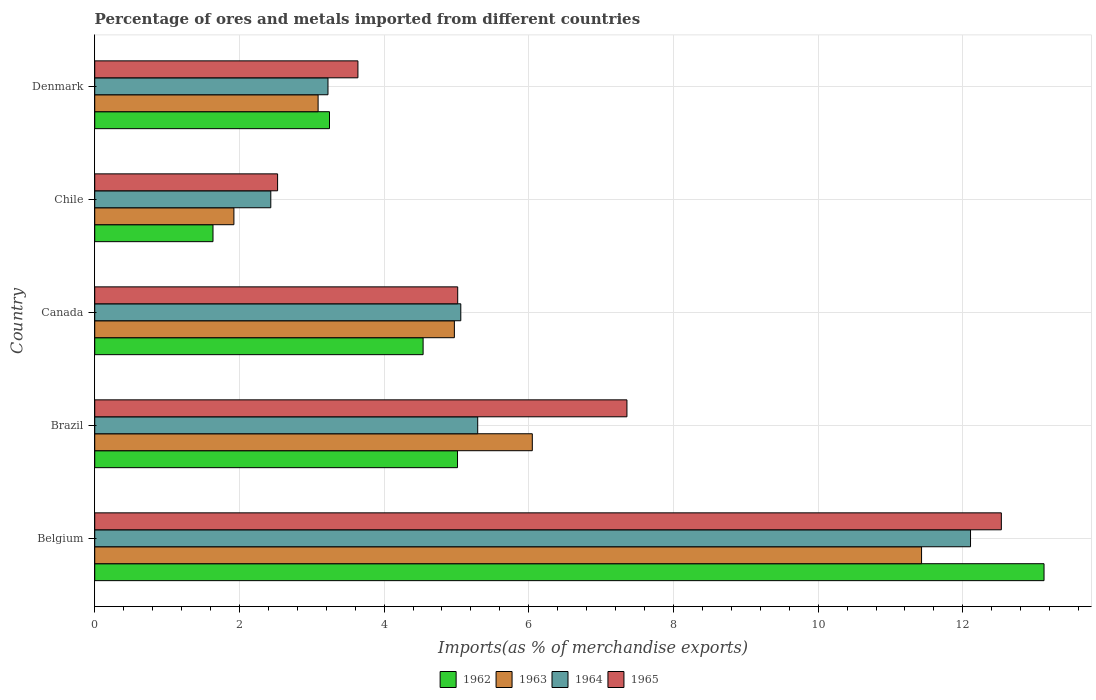How many different coloured bars are there?
Your response must be concise. 4. How many groups of bars are there?
Make the answer very short. 5. How many bars are there on the 1st tick from the bottom?
Give a very brief answer. 4. What is the label of the 2nd group of bars from the top?
Offer a terse response. Chile. What is the percentage of imports to different countries in 1965 in Belgium?
Make the answer very short. 12.53. Across all countries, what is the maximum percentage of imports to different countries in 1964?
Make the answer very short. 12.11. Across all countries, what is the minimum percentage of imports to different countries in 1964?
Your answer should be compact. 2.43. In which country was the percentage of imports to different countries in 1965 minimum?
Keep it short and to the point. Chile. What is the total percentage of imports to different countries in 1963 in the graph?
Offer a terse response. 27.46. What is the difference between the percentage of imports to different countries in 1964 in Belgium and that in Canada?
Ensure brevity in your answer.  7.05. What is the difference between the percentage of imports to different countries in 1963 in Brazil and the percentage of imports to different countries in 1964 in Canada?
Ensure brevity in your answer.  0.99. What is the average percentage of imports to different countries in 1963 per country?
Your answer should be very brief. 5.49. What is the difference between the percentage of imports to different countries in 1962 and percentage of imports to different countries in 1963 in Chile?
Your answer should be very brief. -0.29. What is the ratio of the percentage of imports to different countries in 1964 in Belgium to that in Chile?
Make the answer very short. 4.97. Is the percentage of imports to different countries in 1962 in Chile less than that in Denmark?
Your answer should be compact. Yes. Is the difference between the percentage of imports to different countries in 1962 in Brazil and Canada greater than the difference between the percentage of imports to different countries in 1963 in Brazil and Canada?
Provide a short and direct response. No. What is the difference between the highest and the second highest percentage of imports to different countries in 1965?
Your answer should be very brief. 5.18. What is the difference between the highest and the lowest percentage of imports to different countries in 1964?
Your answer should be compact. 9.67. In how many countries, is the percentage of imports to different countries in 1963 greater than the average percentage of imports to different countries in 1963 taken over all countries?
Your response must be concise. 2. Is the sum of the percentage of imports to different countries in 1965 in Brazil and Chile greater than the maximum percentage of imports to different countries in 1963 across all countries?
Make the answer very short. No. Is it the case that in every country, the sum of the percentage of imports to different countries in 1963 and percentage of imports to different countries in 1964 is greater than the sum of percentage of imports to different countries in 1962 and percentage of imports to different countries in 1965?
Provide a short and direct response. No. What does the 4th bar from the top in Denmark represents?
Make the answer very short. 1962. What does the 3rd bar from the bottom in Chile represents?
Your answer should be compact. 1964. Are all the bars in the graph horizontal?
Your answer should be compact. Yes. How many countries are there in the graph?
Your response must be concise. 5. Does the graph contain any zero values?
Provide a succinct answer. No. Where does the legend appear in the graph?
Your answer should be very brief. Bottom center. How many legend labels are there?
Give a very brief answer. 4. What is the title of the graph?
Keep it short and to the point. Percentage of ores and metals imported from different countries. What is the label or title of the X-axis?
Make the answer very short. Imports(as % of merchandise exports). What is the Imports(as % of merchandise exports) in 1962 in Belgium?
Keep it short and to the point. 13.12. What is the Imports(as % of merchandise exports) in 1963 in Belgium?
Your response must be concise. 11.43. What is the Imports(as % of merchandise exports) of 1964 in Belgium?
Provide a short and direct response. 12.11. What is the Imports(as % of merchandise exports) in 1965 in Belgium?
Provide a succinct answer. 12.53. What is the Imports(as % of merchandise exports) of 1962 in Brazil?
Keep it short and to the point. 5.01. What is the Imports(as % of merchandise exports) of 1963 in Brazil?
Your answer should be very brief. 6.05. What is the Imports(as % of merchandise exports) of 1964 in Brazil?
Your answer should be compact. 5.29. What is the Imports(as % of merchandise exports) in 1965 in Brazil?
Your response must be concise. 7.36. What is the Imports(as % of merchandise exports) of 1962 in Canada?
Provide a short and direct response. 4.54. What is the Imports(as % of merchandise exports) in 1963 in Canada?
Your answer should be very brief. 4.97. What is the Imports(as % of merchandise exports) in 1964 in Canada?
Ensure brevity in your answer.  5.06. What is the Imports(as % of merchandise exports) of 1965 in Canada?
Keep it short and to the point. 5.02. What is the Imports(as % of merchandise exports) of 1962 in Chile?
Offer a terse response. 1.63. What is the Imports(as % of merchandise exports) in 1963 in Chile?
Provide a short and direct response. 1.92. What is the Imports(as % of merchandise exports) in 1964 in Chile?
Offer a very short reply. 2.43. What is the Imports(as % of merchandise exports) of 1965 in Chile?
Your answer should be compact. 2.53. What is the Imports(as % of merchandise exports) in 1962 in Denmark?
Make the answer very short. 3.25. What is the Imports(as % of merchandise exports) of 1963 in Denmark?
Provide a short and direct response. 3.09. What is the Imports(as % of merchandise exports) of 1964 in Denmark?
Offer a terse response. 3.22. What is the Imports(as % of merchandise exports) in 1965 in Denmark?
Ensure brevity in your answer.  3.64. Across all countries, what is the maximum Imports(as % of merchandise exports) in 1962?
Ensure brevity in your answer.  13.12. Across all countries, what is the maximum Imports(as % of merchandise exports) of 1963?
Your response must be concise. 11.43. Across all countries, what is the maximum Imports(as % of merchandise exports) in 1964?
Your answer should be compact. 12.11. Across all countries, what is the maximum Imports(as % of merchandise exports) of 1965?
Your answer should be compact. 12.53. Across all countries, what is the minimum Imports(as % of merchandise exports) of 1962?
Give a very brief answer. 1.63. Across all countries, what is the minimum Imports(as % of merchandise exports) in 1963?
Offer a terse response. 1.92. Across all countries, what is the minimum Imports(as % of merchandise exports) of 1964?
Give a very brief answer. 2.43. Across all countries, what is the minimum Imports(as % of merchandise exports) in 1965?
Provide a short and direct response. 2.53. What is the total Imports(as % of merchandise exports) in 1962 in the graph?
Offer a terse response. 27.56. What is the total Imports(as % of merchandise exports) of 1963 in the graph?
Make the answer very short. 27.46. What is the total Imports(as % of merchandise exports) in 1964 in the graph?
Ensure brevity in your answer.  28.12. What is the total Imports(as % of merchandise exports) of 1965 in the graph?
Your answer should be compact. 31.07. What is the difference between the Imports(as % of merchandise exports) in 1962 in Belgium and that in Brazil?
Offer a terse response. 8.11. What is the difference between the Imports(as % of merchandise exports) of 1963 in Belgium and that in Brazil?
Offer a terse response. 5.38. What is the difference between the Imports(as % of merchandise exports) in 1964 in Belgium and that in Brazil?
Ensure brevity in your answer.  6.81. What is the difference between the Imports(as % of merchandise exports) in 1965 in Belgium and that in Brazil?
Your response must be concise. 5.18. What is the difference between the Imports(as % of merchandise exports) in 1962 in Belgium and that in Canada?
Offer a very short reply. 8.58. What is the difference between the Imports(as % of merchandise exports) of 1963 in Belgium and that in Canada?
Your response must be concise. 6.46. What is the difference between the Imports(as % of merchandise exports) of 1964 in Belgium and that in Canada?
Your response must be concise. 7.05. What is the difference between the Imports(as % of merchandise exports) of 1965 in Belgium and that in Canada?
Give a very brief answer. 7.51. What is the difference between the Imports(as % of merchandise exports) in 1962 in Belgium and that in Chile?
Keep it short and to the point. 11.49. What is the difference between the Imports(as % of merchandise exports) in 1963 in Belgium and that in Chile?
Your response must be concise. 9.51. What is the difference between the Imports(as % of merchandise exports) of 1964 in Belgium and that in Chile?
Your answer should be very brief. 9.67. What is the difference between the Imports(as % of merchandise exports) of 1965 in Belgium and that in Chile?
Your response must be concise. 10. What is the difference between the Imports(as % of merchandise exports) of 1962 in Belgium and that in Denmark?
Provide a succinct answer. 9.88. What is the difference between the Imports(as % of merchandise exports) of 1963 in Belgium and that in Denmark?
Offer a terse response. 8.34. What is the difference between the Imports(as % of merchandise exports) of 1964 in Belgium and that in Denmark?
Your answer should be compact. 8.88. What is the difference between the Imports(as % of merchandise exports) of 1965 in Belgium and that in Denmark?
Ensure brevity in your answer.  8.89. What is the difference between the Imports(as % of merchandise exports) in 1962 in Brazil and that in Canada?
Make the answer very short. 0.48. What is the difference between the Imports(as % of merchandise exports) in 1963 in Brazil and that in Canada?
Provide a short and direct response. 1.08. What is the difference between the Imports(as % of merchandise exports) of 1964 in Brazil and that in Canada?
Keep it short and to the point. 0.23. What is the difference between the Imports(as % of merchandise exports) of 1965 in Brazil and that in Canada?
Make the answer very short. 2.34. What is the difference between the Imports(as % of merchandise exports) in 1962 in Brazil and that in Chile?
Make the answer very short. 3.38. What is the difference between the Imports(as % of merchandise exports) of 1963 in Brazil and that in Chile?
Your response must be concise. 4.12. What is the difference between the Imports(as % of merchandise exports) of 1964 in Brazil and that in Chile?
Your response must be concise. 2.86. What is the difference between the Imports(as % of merchandise exports) in 1965 in Brazil and that in Chile?
Provide a short and direct response. 4.83. What is the difference between the Imports(as % of merchandise exports) of 1962 in Brazil and that in Denmark?
Provide a short and direct response. 1.77. What is the difference between the Imports(as % of merchandise exports) in 1963 in Brazil and that in Denmark?
Ensure brevity in your answer.  2.96. What is the difference between the Imports(as % of merchandise exports) in 1964 in Brazil and that in Denmark?
Offer a very short reply. 2.07. What is the difference between the Imports(as % of merchandise exports) in 1965 in Brazil and that in Denmark?
Your response must be concise. 3.72. What is the difference between the Imports(as % of merchandise exports) in 1962 in Canada and that in Chile?
Your response must be concise. 2.9. What is the difference between the Imports(as % of merchandise exports) in 1963 in Canada and that in Chile?
Offer a terse response. 3.05. What is the difference between the Imports(as % of merchandise exports) in 1964 in Canada and that in Chile?
Your response must be concise. 2.63. What is the difference between the Imports(as % of merchandise exports) of 1965 in Canada and that in Chile?
Your answer should be very brief. 2.49. What is the difference between the Imports(as % of merchandise exports) in 1962 in Canada and that in Denmark?
Offer a terse response. 1.29. What is the difference between the Imports(as % of merchandise exports) in 1963 in Canada and that in Denmark?
Give a very brief answer. 1.88. What is the difference between the Imports(as % of merchandise exports) in 1964 in Canada and that in Denmark?
Keep it short and to the point. 1.84. What is the difference between the Imports(as % of merchandise exports) in 1965 in Canada and that in Denmark?
Offer a terse response. 1.38. What is the difference between the Imports(as % of merchandise exports) in 1962 in Chile and that in Denmark?
Provide a short and direct response. -1.61. What is the difference between the Imports(as % of merchandise exports) in 1963 in Chile and that in Denmark?
Ensure brevity in your answer.  -1.16. What is the difference between the Imports(as % of merchandise exports) in 1964 in Chile and that in Denmark?
Keep it short and to the point. -0.79. What is the difference between the Imports(as % of merchandise exports) in 1965 in Chile and that in Denmark?
Provide a succinct answer. -1.11. What is the difference between the Imports(as % of merchandise exports) of 1962 in Belgium and the Imports(as % of merchandise exports) of 1963 in Brazil?
Offer a terse response. 7.07. What is the difference between the Imports(as % of merchandise exports) of 1962 in Belgium and the Imports(as % of merchandise exports) of 1964 in Brazil?
Provide a short and direct response. 7.83. What is the difference between the Imports(as % of merchandise exports) of 1962 in Belgium and the Imports(as % of merchandise exports) of 1965 in Brazil?
Offer a very short reply. 5.77. What is the difference between the Imports(as % of merchandise exports) of 1963 in Belgium and the Imports(as % of merchandise exports) of 1964 in Brazil?
Make the answer very short. 6.14. What is the difference between the Imports(as % of merchandise exports) of 1963 in Belgium and the Imports(as % of merchandise exports) of 1965 in Brazil?
Give a very brief answer. 4.07. What is the difference between the Imports(as % of merchandise exports) of 1964 in Belgium and the Imports(as % of merchandise exports) of 1965 in Brazil?
Offer a terse response. 4.75. What is the difference between the Imports(as % of merchandise exports) of 1962 in Belgium and the Imports(as % of merchandise exports) of 1963 in Canada?
Keep it short and to the point. 8.15. What is the difference between the Imports(as % of merchandise exports) of 1962 in Belgium and the Imports(as % of merchandise exports) of 1964 in Canada?
Your answer should be very brief. 8.06. What is the difference between the Imports(as % of merchandise exports) in 1962 in Belgium and the Imports(as % of merchandise exports) in 1965 in Canada?
Provide a succinct answer. 8.1. What is the difference between the Imports(as % of merchandise exports) in 1963 in Belgium and the Imports(as % of merchandise exports) in 1964 in Canada?
Make the answer very short. 6.37. What is the difference between the Imports(as % of merchandise exports) of 1963 in Belgium and the Imports(as % of merchandise exports) of 1965 in Canada?
Offer a terse response. 6.41. What is the difference between the Imports(as % of merchandise exports) of 1964 in Belgium and the Imports(as % of merchandise exports) of 1965 in Canada?
Provide a succinct answer. 7.09. What is the difference between the Imports(as % of merchandise exports) in 1962 in Belgium and the Imports(as % of merchandise exports) in 1963 in Chile?
Keep it short and to the point. 11.2. What is the difference between the Imports(as % of merchandise exports) of 1962 in Belgium and the Imports(as % of merchandise exports) of 1964 in Chile?
Offer a very short reply. 10.69. What is the difference between the Imports(as % of merchandise exports) of 1962 in Belgium and the Imports(as % of merchandise exports) of 1965 in Chile?
Your answer should be compact. 10.59. What is the difference between the Imports(as % of merchandise exports) of 1963 in Belgium and the Imports(as % of merchandise exports) of 1964 in Chile?
Provide a short and direct response. 9. What is the difference between the Imports(as % of merchandise exports) in 1963 in Belgium and the Imports(as % of merchandise exports) in 1965 in Chile?
Provide a succinct answer. 8.9. What is the difference between the Imports(as % of merchandise exports) of 1964 in Belgium and the Imports(as % of merchandise exports) of 1965 in Chile?
Offer a very short reply. 9.58. What is the difference between the Imports(as % of merchandise exports) in 1962 in Belgium and the Imports(as % of merchandise exports) in 1963 in Denmark?
Offer a very short reply. 10.03. What is the difference between the Imports(as % of merchandise exports) in 1962 in Belgium and the Imports(as % of merchandise exports) in 1964 in Denmark?
Your answer should be compact. 9.9. What is the difference between the Imports(as % of merchandise exports) of 1962 in Belgium and the Imports(as % of merchandise exports) of 1965 in Denmark?
Offer a very short reply. 9.48. What is the difference between the Imports(as % of merchandise exports) in 1963 in Belgium and the Imports(as % of merchandise exports) in 1964 in Denmark?
Keep it short and to the point. 8.21. What is the difference between the Imports(as % of merchandise exports) in 1963 in Belgium and the Imports(as % of merchandise exports) in 1965 in Denmark?
Offer a terse response. 7.79. What is the difference between the Imports(as % of merchandise exports) in 1964 in Belgium and the Imports(as % of merchandise exports) in 1965 in Denmark?
Offer a very short reply. 8.47. What is the difference between the Imports(as % of merchandise exports) in 1962 in Brazil and the Imports(as % of merchandise exports) in 1963 in Canada?
Provide a short and direct response. 0.04. What is the difference between the Imports(as % of merchandise exports) of 1962 in Brazil and the Imports(as % of merchandise exports) of 1964 in Canada?
Your answer should be very brief. -0.05. What is the difference between the Imports(as % of merchandise exports) in 1962 in Brazil and the Imports(as % of merchandise exports) in 1965 in Canada?
Give a very brief answer. -0. What is the difference between the Imports(as % of merchandise exports) in 1963 in Brazil and the Imports(as % of merchandise exports) in 1964 in Canada?
Your response must be concise. 0.99. What is the difference between the Imports(as % of merchandise exports) of 1963 in Brazil and the Imports(as % of merchandise exports) of 1965 in Canada?
Ensure brevity in your answer.  1.03. What is the difference between the Imports(as % of merchandise exports) in 1964 in Brazil and the Imports(as % of merchandise exports) in 1965 in Canada?
Keep it short and to the point. 0.28. What is the difference between the Imports(as % of merchandise exports) of 1962 in Brazil and the Imports(as % of merchandise exports) of 1963 in Chile?
Offer a very short reply. 3.09. What is the difference between the Imports(as % of merchandise exports) of 1962 in Brazil and the Imports(as % of merchandise exports) of 1964 in Chile?
Your answer should be very brief. 2.58. What is the difference between the Imports(as % of merchandise exports) of 1962 in Brazil and the Imports(as % of merchandise exports) of 1965 in Chile?
Your answer should be very brief. 2.49. What is the difference between the Imports(as % of merchandise exports) in 1963 in Brazil and the Imports(as % of merchandise exports) in 1964 in Chile?
Offer a terse response. 3.61. What is the difference between the Imports(as % of merchandise exports) in 1963 in Brazil and the Imports(as % of merchandise exports) in 1965 in Chile?
Your answer should be very brief. 3.52. What is the difference between the Imports(as % of merchandise exports) in 1964 in Brazil and the Imports(as % of merchandise exports) in 1965 in Chile?
Provide a succinct answer. 2.77. What is the difference between the Imports(as % of merchandise exports) of 1962 in Brazil and the Imports(as % of merchandise exports) of 1963 in Denmark?
Offer a very short reply. 1.93. What is the difference between the Imports(as % of merchandise exports) in 1962 in Brazil and the Imports(as % of merchandise exports) in 1964 in Denmark?
Your answer should be compact. 1.79. What is the difference between the Imports(as % of merchandise exports) in 1962 in Brazil and the Imports(as % of merchandise exports) in 1965 in Denmark?
Offer a terse response. 1.38. What is the difference between the Imports(as % of merchandise exports) in 1963 in Brazil and the Imports(as % of merchandise exports) in 1964 in Denmark?
Provide a short and direct response. 2.82. What is the difference between the Imports(as % of merchandise exports) in 1963 in Brazil and the Imports(as % of merchandise exports) in 1965 in Denmark?
Offer a terse response. 2.41. What is the difference between the Imports(as % of merchandise exports) in 1964 in Brazil and the Imports(as % of merchandise exports) in 1965 in Denmark?
Make the answer very short. 1.66. What is the difference between the Imports(as % of merchandise exports) in 1962 in Canada and the Imports(as % of merchandise exports) in 1963 in Chile?
Make the answer very short. 2.62. What is the difference between the Imports(as % of merchandise exports) in 1962 in Canada and the Imports(as % of merchandise exports) in 1964 in Chile?
Provide a succinct answer. 2.11. What is the difference between the Imports(as % of merchandise exports) of 1962 in Canada and the Imports(as % of merchandise exports) of 1965 in Chile?
Your answer should be compact. 2.01. What is the difference between the Imports(as % of merchandise exports) of 1963 in Canada and the Imports(as % of merchandise exports) of 1964 in Chile?
Your answer should be compact. 2.54. What is the difference between the Imports(as % of merchandise exports) in 1963 in Canada and the Imports(as % of merchandise exports) in 1965 in Chile?
Provide a short and direct response. 2.44. What is the difference between the Imports(as % of merchandise exports) of 1964 in Canada and the Imports(as % of merchandise exports) of 1965 in Chile?
Give a very brief answer. 2.53. What is the difference between the Imports(as % of merchandise exports) of 1962 in Canada and the Imports(as % of merchandise exports) of 1963 in Denmark?
Ensure brevity in your answer.  1.45. What is the difference between the Imports(as % of merchandise exports) in 1962 in Canada and the Imports(as % of merchandise exports) in 1964 in Denmark?
Offer a very short reply. 1.31. What is the difference between the Imports(as % of merchandise exports) in 1962 in Canada and the Imports(as % of merchandise exports) in 1965 in Denmark?
Your answer should be compact. 0.9. What is the difference between the Imports(as % of merchandise exports) of 1963 in Canada and the Imports(as % of merchandise exports) of 1964 in Denmark?
Your answer should be very brief. 1.75. What is the difference between the Imports(as % of merchandise exports) of 1963 in Canada and the Imports(as % of merchandise exports) of 1965 in Denmark?
Keep it short and to the point. 1.33. What is the difference between the Imports(as % of merchandise exports) of 1964 in Canada and the Imports(as % of merchandise exports) of 1965 in Denmark?
Your answer should be very brief. 1.42. What is the difference between the Imports(as % of merchandise exports) in 1962 in Chile and the Imports(as % of merchandise exports) in 1963 in Denmark?
Give a very brief answer. -1.45. What is the difference between the Imports(as % of merchandise exports) in 1962 in Chile and the Imports(as % of merchandise exports) in 1964 in Denmark?
Your answer should be very brief. -1.59. What is the difference between the Imports(as % of merchandise exports) of 1962 in Chile and the Imports(as % of merchandise exports) of 1965 in Denmark?
Your answer should be compact. -2. What is the difference between the Imports(as % of merchandise exports) of 1963 in Chile and the Imports(as % of merchandise exports) of 1964 in Denmark?
Keep it short and to the point. -1.3. What is the difference between the Imports(as % of merchandise exports) of 1963 in Chile and the Imports(as % of merchandise exports) of 1965 in Denmark?
Your answer should be compact. -1.71. What is the difference between the Imports(as % of merchandise exports) of 1964 in Chile and the Imports(as % of merchandise exports) of 1965 in Denmark?
Provide a short and direct response. -1.2. What is the average Imports(as % of merchandise exports) of 1962 per country?
Give a very brief answer. 5.51. What is the average Imports(as % of merchandise exports) of 1963 per country?
Make the answer very short. 5.49. What is the average Imports(as % of merchandise exports) in 1964 per country?
Your answer should be compact. 5.62. What is the average Imports(as % of merchandise exports) of 1965 per country?
Offer a terse response. 6.21. What is the difference between the Imports(as % of merchandise exports) in 1962 and Imports(as % of merchandise exports) in 1963 in Belgium?
Make the answer very short. 1.69. What is the difference between the Imports(as % of merchandise exports) in 1962 and Imports(as % of merchandise exports) in 1965 in Belgium?
Your answer should be very brief. 0.59. What is the difference between the Imports(as % of merchandise exports) in 1963 and Imports(as % of merchandise exports) in 1964 in Belgium?
Make the answer very short. -0.68. What is the difference between the Imports(as % of merchandise exports) of 1963 and Imports(as % of merchandise exports) of 1965 in Belgium?
Give a very brief answer. -1.1. What is the difference between the Imports(as % of merchandise exports) of 1964 and Imports(as % of merchandise exports) of 1965 in Belgium?
Keep it short and to the point. -0.43. What is the difference between the Imports(as % of merchandise exports) of 1962 and Imports(as % of merchandise exports) of 1963 in Brazil?
Give a very brief answer. -1.03. What is the difference between the Imports(as % of merchandise exports) in 1962 and Imports(as % of merchandise exports) in 1964 in Brazil?
Provide a short and direct response. -0.28. What is the difference between the Imports(as % of merchandise exports) in 1962 and Imports(as % of merchandise exports) in 1965 in Brazil?
Keep it short and to the point. -2.34. What is the difference between the Imports(as % of merchandise exports) in 1963 and Imports(as % of merchandise exports) in 1964 in Brazil?
Keep it short and to the point. 0.75. What is the difference between the Imports(as % of merchandise exports) of 1963 and Imports(as % of merchandise exports) of 1965 in Brazil?
Your answer should be compact. -1.31. What is the difference between the Imports(as % of merchandise exports) in 1964 and Imports(as % of merchandise exports) in 1965 in Brazil?
Keep it short and to the point. -2.06. What is the difference between the Imports(as % of merchandise exports) in 1962 and Imports(as % of merchandise exports) in 1963 in Canada?
Keep it short and to the point. -0.43. What is the difference between the Imports(as % of merchandise exports) in 1962 and Imports(as % of merchandise exports) in 1964 in Canada?
Provide a succinct answer. -0.52. What is the difference between the Imports(as % of merchandise exports) in 1962 and Imports(as % of merchandise exports) in 1965 in Canada?
Offer a terse response. -0.48. What is the difference between the Imports(as % of merchandise exports) in 1963 and Imports(as % of merchandise exports) in 1964 in Canada?
Make the answer very short. -0.09. What is the difference between the Imports(as % of merchandise exports) of 1963 and Imports(as % of merchandise exports) of 1965 in Canada?
Your answer should be compact. -0.05. What is the difference between the Imports(as % of merchandise exports) of 1964 and Imports(as % of merchandise exports) of 1965 in Canada?
Provide a short and direct response. 0.04. What is the difference between the Imports(as % of merchandise exports) of 1962 and Imports(as % of merchandise exports) of 1963 in Chile?
Make the answer very short. -0.29. What is the difference between the Imports(as % of merchandise exports) of 1962 and Imports(as % of merchandise exports) of 1964 in Chile?
Provide a short and direct response. -0.8. What is the difference between the Imports(as % of merchandise exports) of 1962 and Imports(as % of merchandise exports) of 1965 in Chile?
Make the answer very short. -0.89. What is the difference between the Imports(as % of merchandise exports) in 1963 and Imports(as % of merchandise exports) in 1964 in Chile?
Offer a terse response. -0.51. What is the difference between the Imports(as % of merchandise exports) in 1963 and Imports(as % of merchandise exports) in 1965 in Chile?
Make the answer very short. -0.6. What is the difference between the Imports(as % of merchandise exports) of 1964 and Imports(as % of merchandise exports) of 1965 in Chile?
Your answer should be very brief. -0.09. What is the difference between the Imports(as % of merchandise exports) in 1962 and Imports(as % of merchandise exports) in 1963 in Denmark?
Your answer should be very brief. 0.16. What is the difference between the Imports(as % of merchandise exports) of 1962 and Imports(as % of merchandise exports) of 1964 in Denmark?
Offer a terse response. 0.02. What is the difference between the Imports(as % of merchandise exports) in 1962 and Imports(as % of merchandise exports) in 1965 in Denmark?
Your answer should be very brief. -0.39. What is the difference between the Imports(as % of merchandise exports) of 1963 and Imports(as % of merchandise exports) of 1964 in Denmark?
Provide a short and direct response. -0.14. What is the difference between the Imports(as % of merchandise exports) of 1963 and Imports(as % of merchandise exports) of 1965 in Denmark?
Provide a short and direct response. -0.55. What is the difference between the Imports(as % of merchandise exports) of 1964 and Imports(as % of merchandise exports) of 1965 in Denmark?
Offer a very short reply. -0.41. What is the ratio of the Imports(as % of merchandise exports) of 1962 in Belgium to that in Brazil?
Your answer should be compact. 2.62. What is the ratio of the Imports(as % of merchandise exports) of 1963 in Belgium to that in Brazil?
Your answer should be very brief. 1.89. What is the ratio of the Imports(as % of merchandise exports) of 1964 in Belgium to that in Brazil?
Provide a short and direct response. 2.29. What is the ratio of the Imports(as % of merchandise exports) in 1965 in Belgium to that in Brazil?
Offer a very short reply. 1.7. What is the ratio of the Imports(as % of merchandise exports) in 1962 in Belgium to that in Canada?
Provide a succinct answer. 2.89. What is the ratio of the Imports(as % of merchandise exports) of 1963 in Belgium to that in Canada?
Give a very brief answer. 2.3. What is the ratio of the Imports(as % of merchandise exports) in 1964 in Belgium to that in Canada?
Your response must be concise. 2.39. What is the ratio of the Imports(as % of merchandise exports) in 1965 in Belgium to that in Canada?
Give a very brief answer. 2.5. What is the ratio of the Imports(as % of merchandise exports) of 1962 in Belgium to that in Chile?
Ensure brevity in your answer.  8.03. What is the ratio of the Imports(as % of merchandise exports) in 1963 in Belgium to that in Chile?
Make the answer very short. 5.94. What is the ratio of the Imports(as % of merchandise exports) in 1964 in Belgium to that in Chile?
Provide a succinct answer. 4.97. What is the ratio of the Imports(as % of merchandise exports) of 1965 in Belgium to that in Chile?
Your answer should be compact. 4.96. What is the ratio of the Imports(as % of merchandise exports) in 1962 in Belgium to that in Denmark?
Your answer should be very brief. 4.04. What is the ratio of the Imports(as % of merchandise exports) of 1963 in Belgium to that in Denmark?
Offer a terse response. 3.7. What is the ratio of the Imports(as % of merchandise exports) in 1964 in Belgium to that in Denmark?
Make the answer very short. 3.75. What is the ratio of the Imports(as % of merchandise exports) in 1965 in Belgium to that in Denmark?
Keep it short and to the point. 3.44. What is the ratio of the Imports(as % of merchandise exports) of 1962 in Brazil to that in Canada?
Keep it short and to the point. 1.1. What is the ratio of the Imports(as % of merchandise exports) of 1963 in Brazil to that in Canada?
Give a very brief answer. 1.22. What is the ratio of the Imports(as % of merchandise exports) in 1964 in Brazil to that in Canada?
Your answer should be very brief. 1.05. What is the ratio of the Imports(as % of merchandise exports) of 1965 in Brazil to that in Canada?
Offer a terse response. 1.47. What is the ratio of the Imports(as % of merchandise exports) of 1962 in Brazil to that in Chile?
Your response must be concise. 3.07. What is the ratio of the Imports(as % of merchandise exports) of 1963 in Brazil to that in Chile?
Your answer should be compact. 3.14. What is the ratio of the Imports(as % of merchandise exports) in 1964 in Brazil to that in Chile?
Your answer should be compact. 2.18. What is the ratio of the Imports(as % of merchandise exports) of 1965 in Brazil to that in Chile?
Your answer should be very brief. 2.91. What is the ratio of the Imports(as % of merchandise exports) of 1962 in Brazil to that in Denmark?
Keep it short and to the point. 1.55. What is the ratio of the Imports(as % of merchandise exports) of 1963 in Brazil to that in Denmark?
Offer a terse response. 1.96. What is the ratio of the Imports(as % of merchandise exports) of 1964 in Brazil to that in Denmark?
Provide a short and direct response. 1.64. What is the ratio of the Imports(as % of merchandise exports) of 1965 in Brazil to that in Denmark?
Provide a succinct answer. 2.02. What is the ratio of the Imports(as % of merchandise exports) in 1962 in Canada to that in Chile?
Your answer should be compact. 2.78. What is the ratio of the Imports(as % of merchandise exports) of 1963 in Canada to that in Chile?
Your answer should be very brief. 2.58. What is the ratio of the Imports(as % of merchandise exports) in 1964 in Canada to that in Chile?
Make the answer very short. 2.08. What is the ratio of the Imports(as % of merchandise exports) in 1965 in Canada to that in Chile?
Ensure brevity in your answer.  1.99. What is the ratio of the Imports(as % of merchandise exports) in 1962 in Canada to that in Denmark?
Your response must be concise. 1.4. What is the ratio of the Imports(as % of merchandise exports) of 1963 in Canada to that in Denmark?
Give a very brief answer. 1.61. What is the ratio of the Imports(as % of merchandise exports) in 1964 in Canada to that in Denmark?
Provide a succinct answer. 1.57. What is the ratio of the Imports(as % of merchandise exports) of 1965 in Canada to that in Denmark?
Make the answer very short. 1.38. What is the ratio of the Imports(as % of merchandise exports) of 1962 in Chile to that in Denmark?
Keep it short and to the point. 0.5. What is the ratio of the Imports(as % of merchandise exports) in 1963 in Chile to that in Denmark?
Your answer should be compact. 0.62. What is the ratio of the Imports(as % of merchandise exports) in 1964 in Chile to that in Denmark?
Make the answer very short. 0.75. What is the ratio of the Imports(as % of merchandise exports) in 1965 in Chile to that in Denmark?
Give a very brief answer. 0.69. What is the difference between the highest and the second highest Imports(as % of merchandise exports) in 1962?
Your response must be concise. 8.11. What is the difference between the highest and the second highest Imports(as % of merchandise exports) in 1963?
Make the answer very short. 5.38. What is the difference between the highest and the second highest Imports(as % of merchandise exports) of 1964?
Provide a short and direct response. 6.81. What is the difference between the highest and the second highest Imports(as % of merchandise exports) in 1965?
Offer a very short reply. 5.18. What is the difference between the highest and the lowest Imports(as % of merchandise exports) of 1962?
Make the answer very short. 11.49. What is the difference between the highest and the lowest Imports(as % of merchandise exports) in 1963?
Give a very brief answer. 9.51. What is the difference between the highest and the lowest Imports(as % of merchandise exports) of 1964?
Keep it short and to the point. 9.67. What is the difference between the highest and the lowest Imports(as % of merchandise exports) of 1965?
Ensure brevity in your answer.  10. 